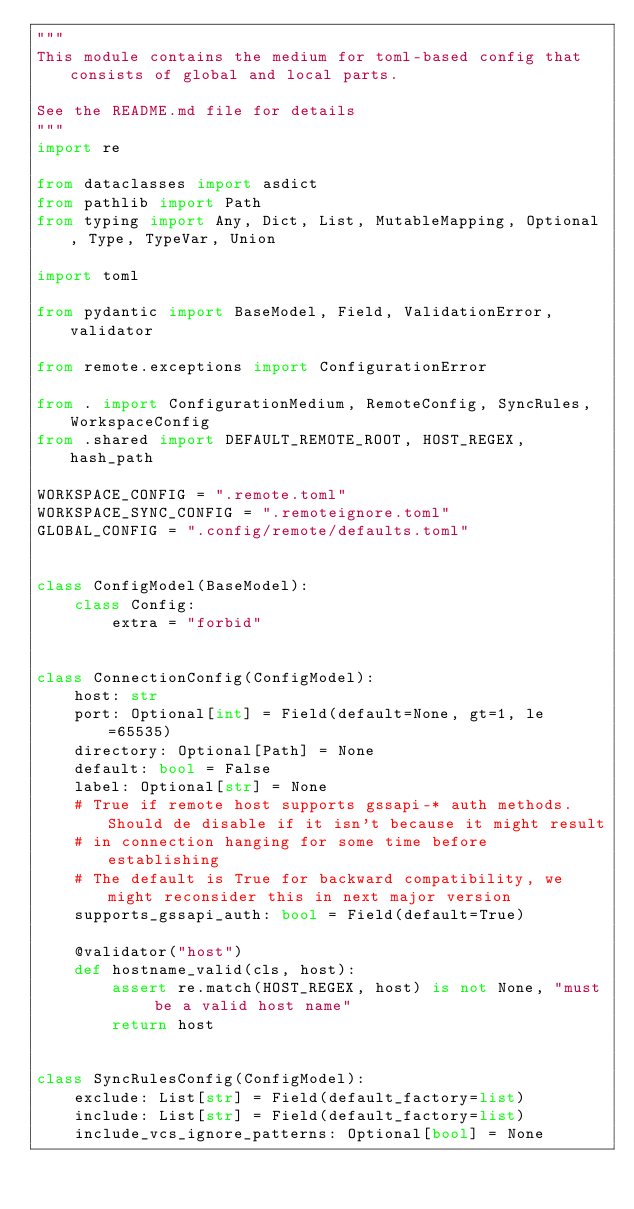Convert code to text. <code><loc_0><loc_0><loc_500><loc_500><_Python_>"""
This module contains the medium for toml-based config that consists of global and local parts.

See the README.md file for details
"""
import re

from dataclasses import asdict
from pathlib import Path
from typing import Any, Dict, List, MutableMapping, Optional, Type, TypeVar, Union

import toml

from pydantic import BaseModel, Field, ValidationError, validator

from remote.exceptions import ConfigurationError

from . import ConfigurationMedium, RemoteConfig, SyncRules, WorkspaceConfig
from .shared import DEFAULT_REMOTE_ROOT, HOST_REGEX, hash_path

WORKSPACE_CONFIG = ".remote.toml"
WORKSPACE_SYNC_CONFIG = ".remoteignore.toml"
GLOBAL_CONFIG = ".config/remote/defaults.toml"


class ConfigModel(BaseModel):
    class Config:
        extra = "forbid"


class ConnectionConfig(ConfigModel):
    host: str
    port: Optional[int] = Field(default=None, gt=1, le=65535)
    directory: Optional[Path] = None
    default: bool = False
    label: Optional[str] = None
    # True if remote host supports gssapi-* auth methods. Should de disable if it isn't because it might result
    # in connection hanging for some time before establishing
    # The default is True for backward compatibility, we might reconsider this in next major version
    supports_gssapi_auth: bool = Field(default=True)

    @validator("host")
    def hostname_valid(cls, host):
        assert re.match(HOST_REGEX, host) is not None, "must be a valid host name"
        return host


class SyncRulesConfig(ConfigModel):
    exclude: List[str] = Field(default_factory=list)
    include: List[str] = Field(default_factory=list)
    include_vcs_ignore_patterns: Optional[bool] = None
</code> 